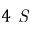<formula> <loc_0><loc_0><loc_500><loc_500>4 S</formula> 